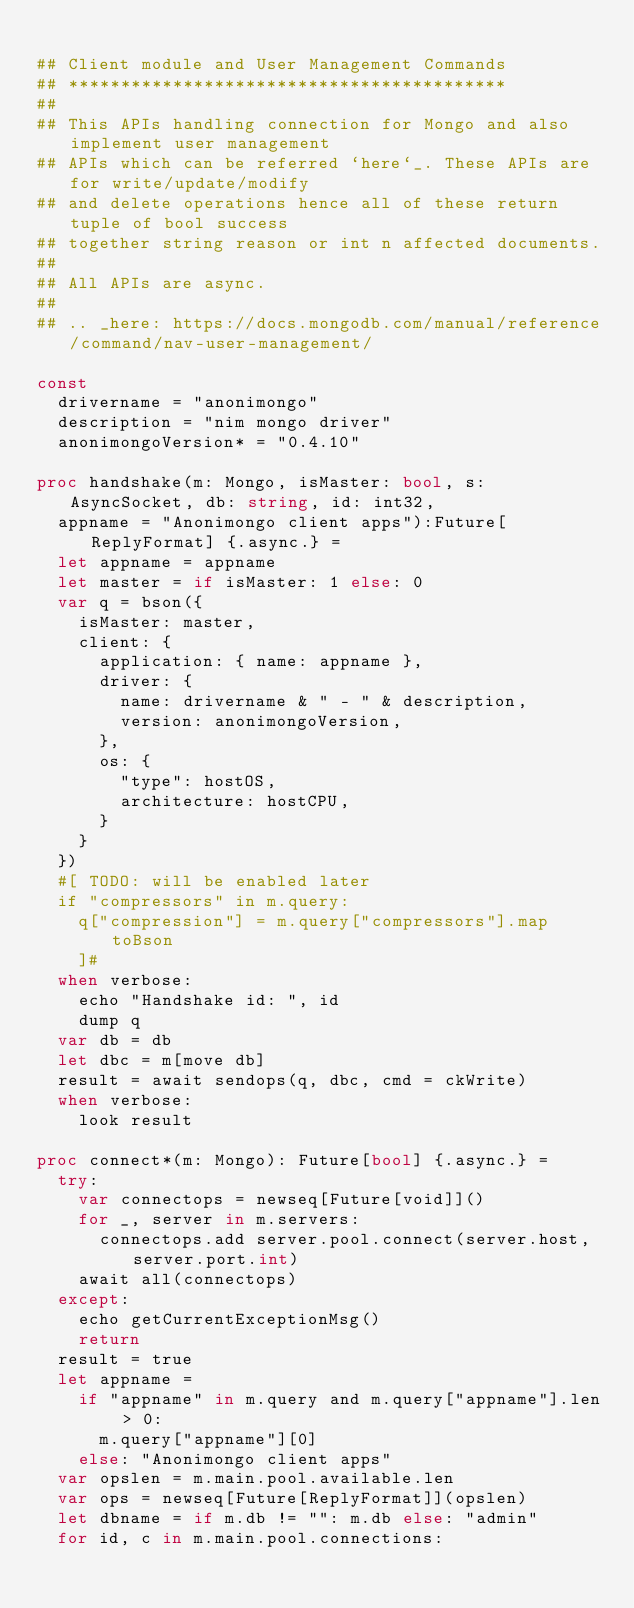<code> <loc_0><loc_0><loc_500><loc_500><_Nim_>
## Client module and User Management Commands
## ******************************************
##
## This APIs handling connection for Mongo and also implement user management
## APIs which can be referred `here`_. These APIs are for write/update/modify
## and delete operations hence all of these return tuple of bool success
## together string reason or int n affected documents.
##
## All APIs are async.
##
## .. _here: https://docs.mongodb.com/manual/reference/command/nav-user-management/

const
  drivername = "anonimongo"
  description = "nim mongo driver"
  anonimongoVersion* = "0.4.10"

proc handshake(m: Mongo, isMaster: bool, s: AsyncSocket, db: string, id: int32,
  appname = "Anonimongo client apps"):Future[ReplyFormat] {.async.} =
  let appname = appname
  let master = if isMaster: 1 else: 0
  var q = bson({
    isMaster: master,
    client: {
      application: { name: appname },
      driver: {
        name: drivername & " - " & description,
        version: anonimongoVersion,
      },
      os: {
        "type": hostOS,
        architecture: hostCPU,
      }
    }
  })
  #[ TODO: will be enabled later
  if "compressors" in m.query:
    q["compression"] = m.query["compressors"].map toBson
    ]#
  when verbose:
    echo "Handshake id: ", id
    dump q
  var db = db
  let dbc = m[move db]
  result = await sendops(q, dbc, cmd = ckWrite)
  when verbose:
    look result

proc connect*(m: Mongo): Future[bool] {.async.} =
  try:
    var connectops = newseq[Future[void]]()
    for _, server in m.servers:
      connectops.add server.pool.connect(server.host, server.port.int)
    await all(connectops)
  except:
    echo getCurrentExceptionMsg()
    return
  result = true
  let appname =
    if "appname" in m.query and m.query["appname"].len > 0:
      m.query["appname"][0]
    else: "Anonimongo client apps"
  var opslen = m.main.pool.available.len
  var ops = newseq[Future[ReplyFormat]](opslen)
  let dbname = if m.db != "": m.db else: "admin"
  for id, c in m.main.pool.connections:</code> 